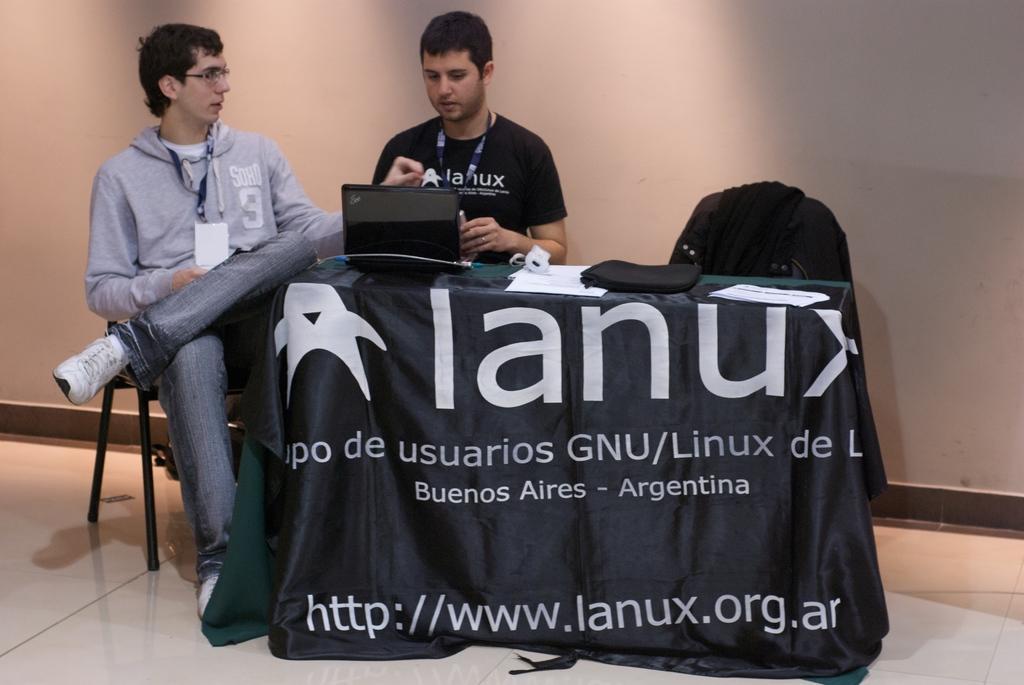How would you summarize this image in a sentence or two? There are two people sitting and talking with each other. In front of the person in black color t-shirt, there is a laptop on the table which is on the floor. In the background, there is a white color wall. 